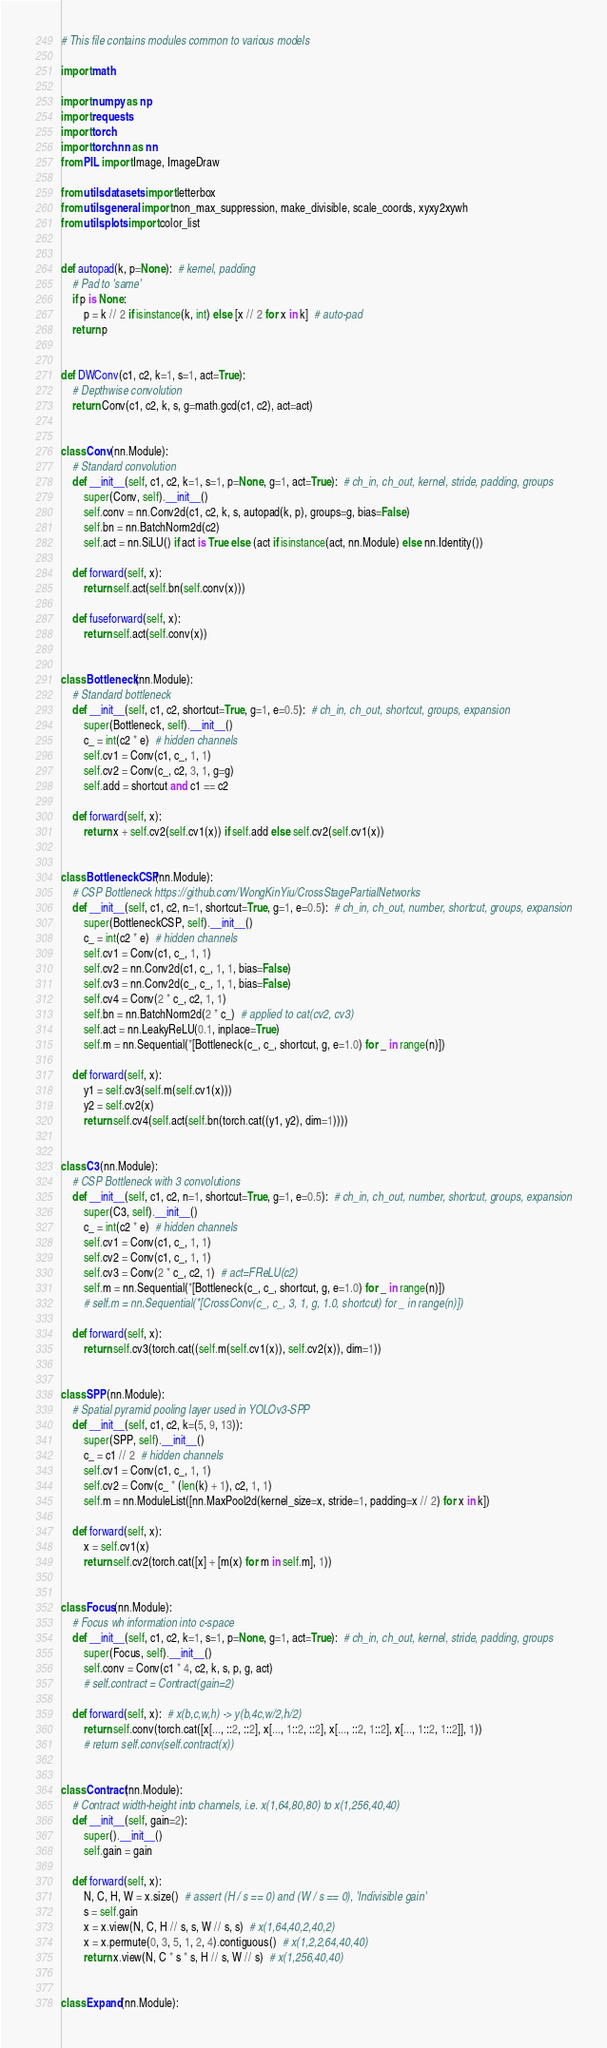<code> <loc_0><loc_0><loc_500><loc_500><_Python_># This file contains modules common to various models

import math

import numpy as np
import requests
import torch
import torch.nn as nn
from PIL import Image, ImageDraw

from utils.datasets import letterbox
from utils.general import non_max_suppression, make_divisible, scale_coords, xyxy2xywh
from utils.plots import color_list


def autopad(k, p=None):  # kernel, padding
    # Pad to 'same'
    if p is None:
        p = k // 2 if isinstance(k, int) else [x // 2 for x in k]  # auto-pad
    return p


def DWConv(c1, c2, k=1, s=1, act=True):
    # Depthwise convolution
    return Conv(c1, c2, k, s, g=math.gcd(c1, c2), act=act)


class Conv(nn.Module):
    # Standard convolution
    def __init__(self, c1, c2, k=1, s=1, p=None, g=1, act=True):  # ch_in, ch_out, kernel, stride, padding, groups
        super(Conv, self).__init__()
        self.conv = nn.Conv2d(c1, c2, k, s, autopad(k, p), groups=g, bias=False)
        self.bn = nn.BatchNorm2d(c2)
        self.act = nn.SiLU() if act is True else (act if isinstance(act, nn.Module) else nn.Identity())

    def forward(self, x):
        return self.act(self.bn(self.conv(x)))

    def fuseforward(self, x):
        return self.act(self.conv(x))


class Bottleneck(nn.Module):
    # Standard bottleneck
    def __init__(self, c1, c2, shortcut=True, g=1, e=0.5):  # ch_in, ch_out, shortcut, groups, expansion
        super(Bottleneck, self).__init__()
        c_ = int(c2 * e)  # hidden channels
        self.cv1 = Conv(c1, c_, 1, 1)
        self.cv2 = Conv(c_, c2, 3, 1, g=g)
        self.add = shortcut and c1 == c2

    def forward(self, x):
        return x + self.cv2(self.cv1(x)) if self.add else self.cv2(self.cv1(x))


class BottleneckCSP(nn.Module):
    # CSP Bottleneck https://github.com/WongKinYiu/CrossStagePartialNetworks
    def __init__(self, c1, c2, n=1, shortcut=True, g=1, e=0.5):  # ch_in, ch_out, number, shortcut, groups, expansion
        super(BottleneckCSP, self).__init__()
        c_ = int(c2 * e)  # hidden channels
        self.cv1 = Conv(c1, c_, 1, 1)
        self.cv2 = nn.Conv2d(c1, c_, 1, 1, bias=False)
        self.cv3 = nn.Conv2d(c_, c_, 1, 1, bias=False)
        self.cv4 = Conv(2 * c_, c2, 1, 1)
        self.bn = nn.BatchNorm2d(2 * c_)  # applied to cat(cv2, cv3)
        self.act = nn.LeakyReLU(0.1, inplace=True)
        self.m = nn.Sequential(*[Bottleneck(c_, c_, shortcut, g, e=1.0) for _ in range(n)])

    def forward(self, x):
        y1 = self.cv3(self.m(self.cv1(x)))
        y2 = self.cv2(x)
        return self.cv4(self.act(self.bn(torch.cat((y1, y2), dim=1))))


class C3(nn.Module):
    # CSP Bottleneck with 3 convolutions
    def __init__(self, c1, c2, n=1, shortcut=True, g=1, e=0.5):  # ch_in, ch_out, number, shortcut, groups, expansion
        super(C3, self).__init__()
        c_ = int(c2 * e)  # hidden channels
        self.cv1 = Conv(c1, c_, 1, 1)
        self.cv2 = Conv(c1, c_, 1, 1)
        self.cv3 = Conv(2 * c_, c2, 1)  # act=FReLU(c2)
        self.m = nn.Sequential(*[Bottleneck(c_, c_, shortcut, g, e=1.0) for _ in range(n)])
        # self.m = nn.Sequential(*[CrossConv(c_, c_, 3, 1, g, 1.0, shortcut) for _ in range(n)])

    def forward(self, x):
        return self.cv3(torch.cat((self.m(self.cv1(x)), self.cv2(x)), dim=1))


class SPP(nn.Module):
    # Spatial pyramid pooling layer used in YOLOv3-SPP
    def __init__(self, c1, c2, k=(5, 9, 13)):
        super(SPP, self).__init__()
        c_ = c1 // 2  # hidden channels
        self.cv1 = Conv(c1, c_, 1, 1)
        self.cv2 = Conv(c_ * (len(k) + 1), c2, 1, 1)
        self.m = nn.ModuleList([nn.MaxPool2d(kernel_size=x, stride=1, padding=x // 2) for x in k])

    def forward(self, x):
        x = self.cv1(x)
        return self.cv2(torch.cat([x] + [m(x) for m in self.m], 1))


class Focus(nn.Module):
    # Focus wh information into c-space
    def __init__(self, c1, c2, k=1, s=1, p=None, g=1, act=True):  # ch_in, ch_out, kernel, stride, padding, groups
        super(Focus, self).__init__()
        self.conv = Conv(c1 * 4, c2, k, s, p, g, act)
        # self.contract = Contract(gain=2)

    def forward(self, x):  # x(b,c,w,h) -> y(b,4c,w/2,h/2)
        return self.conv(torch.cat([x[..., ::2, ::2], x[..., 1::2, ::2], x[..., ::2, 1::2], x[..., 1::2, 1::2]], 1))
        # return self.conv(self.contract(x))


class Contract(nn.Module):
    # Contract width-height into channels, i.e. x(1,64,80,80) to x(1,256,40,40)
    def __init__(self, gain=2):
        super().__init__()
        self.gain = gain

    def forward(self, x):
        N, C, H, W = x.size()  # assert (H / s == 0) and (W / s == 0), 'Indivisible gain'
        s = self.gain
        x = x.view(N, C, H // s, s, W // s, s)  # x(1,64,40,2,40,2)
        x = x.permute(0, 3, 5, 1, 2, 4).contiguous()  # x(1,2,2,64,40,40)
        return x.view(N, C * s * s, H // s, W // s)  # x(1,256,40,40)


class Expand(nn.Module):</code> 